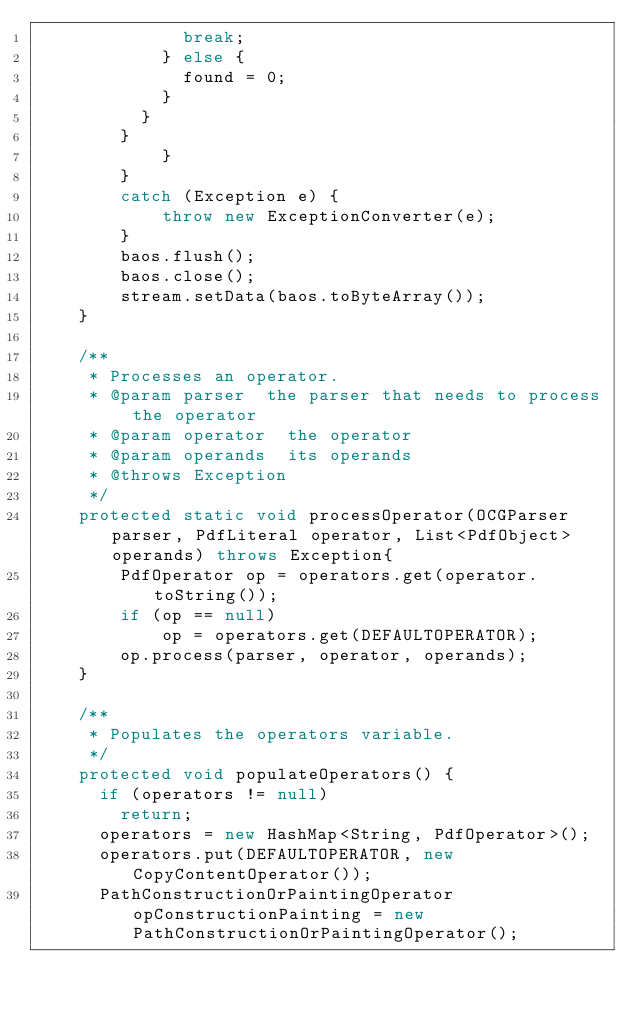<code> <loc_0><loc_0><loc_500><loc_500><_Java_>							break;
						} else {
							found = 0;
						}
					}
				}
            }
        }
        catch (Exception e) {
            throw new ExceptionConverter(e);
        }
        baos.flush();
        baos.close();
        stream.setData(baos.toByteArray());
    }
    
    /**
     * Processes an operator.
     * @param parser	the parser that needs to process the operator
     * @param operator	the operator
     * @param operands	its operands
     * @throws Exception
     */
    protected static void processOperator(OCGParser parser, PdfLiteral operator, List<PdfObject> operands) throws Exception{
        PdfOperator op = operators.get(operator.toString());
        if (op == null)
            op = operators.get(DEFAULTOPERATOR);
        op.process(parser, operator, operands);
    }

    /**
     * Populates the operators variable.
     */
    protected void populateOperators() {
    	if (operators != null)
    		return;
    	operators = new HashMap<String, PdfOperator>();
    	operators.put(DEFAULTOPERATOR, new CopyContentOperator());
    	PathConstructionOrPaintingOperator opConstructionPainting = new PathConstructionOrPaintingOperator();</code> 